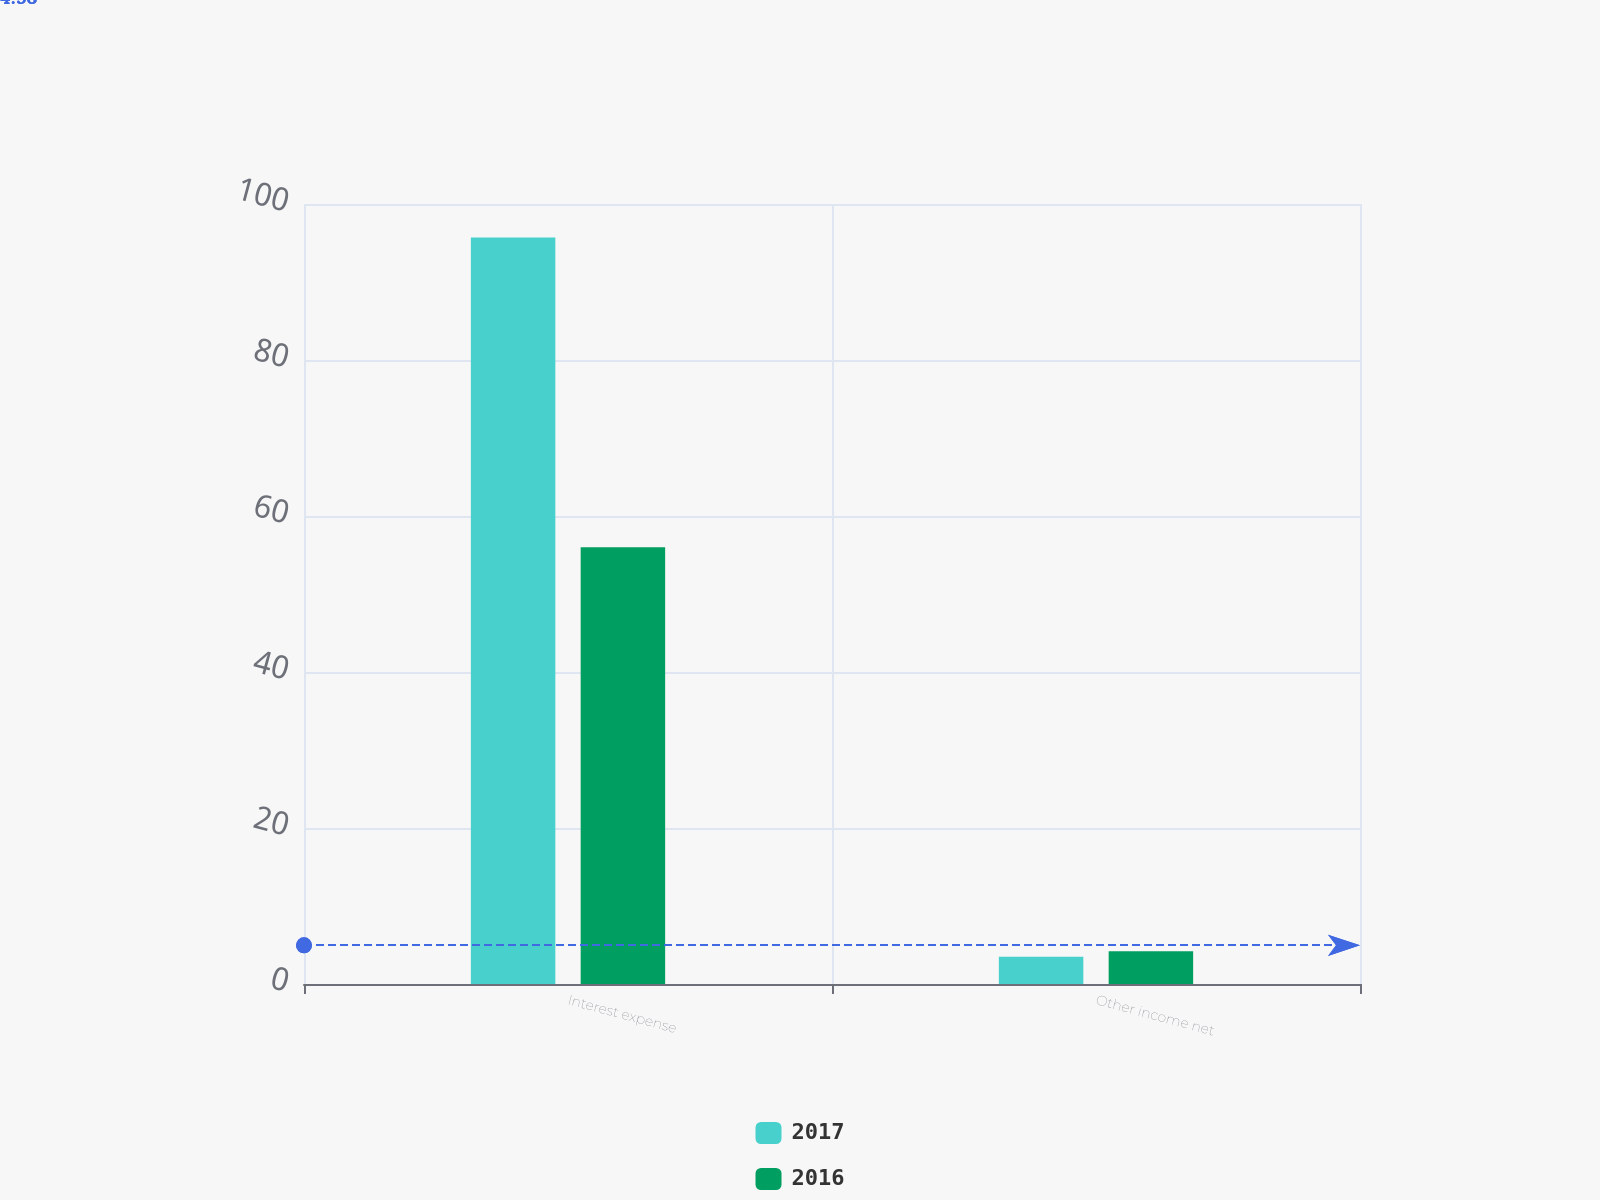Convert chart. <chart><loc_0><loc_0><loc_500><loc_500><stacked_bar_chart><ecel><fcel>Interest expense<fcel>Other income net<nl><fcel>2017<fcel>95.7<fcel>3.5<nl><fcel>2016<fcel>56<fcel>4.2<nl></chart> 